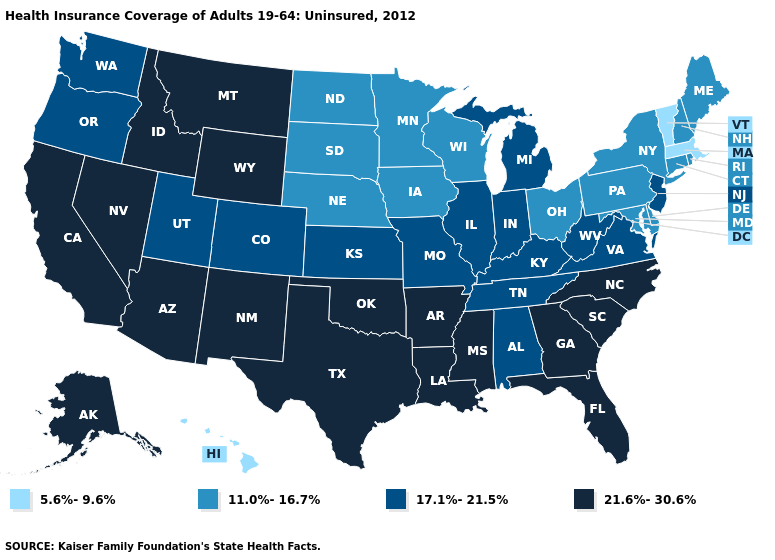What is the value of Montana?
Write a very short answer. 21.6%-30.6%. Does Vermont have the lowest value in the USA?
Give a very brief answer. Yes. What is the highest value in states that border Indiana?
Concise answer only. 17.1%-21.5%. What is the value of New Jersey?
Concise answer only. 17.1%-21.5%. What is the value of Nebraska?
Give a very brief answer. 11.0%-16.7%. What is the value of Maine?
Keep it brief. 11.0%-16.7%. Does Arizona have the same value as Indiana?
Short answer required. No. Name the states that have a value in the range 21.6%-30.6%?
Concise answer only. Alaska, Arizona, Arkansas, California, Florida, Georgia, Idaho, Louisiana, Mississippi, Montana, Nevada, New Mexico, North Carolina, Oklahoma, South Carolina, Texas, Wyoming. What is the value of Virginia?
Quick response, please. 17.1%-21.5%. Does Delaware have the lowest value in the South?
Give a very brief answer. Yes. Among the states that border Tennessee , does Arkansas have the highest value?
Give a very brief answer. Yes. What is the highest value in states that border Oklahoma?
Give a very brief answer. 21.6%-30.6%. Which states have the highest value in the USA?
Answer briefly. Alaska, Arizona, Arkansas, California, Florida, Georgia, Idaho, Louisiana, Mississippi, Montana, Nevada, New Mexico, North Carolina, Oklahoma, South Carolina, Texas, Wyoming. 